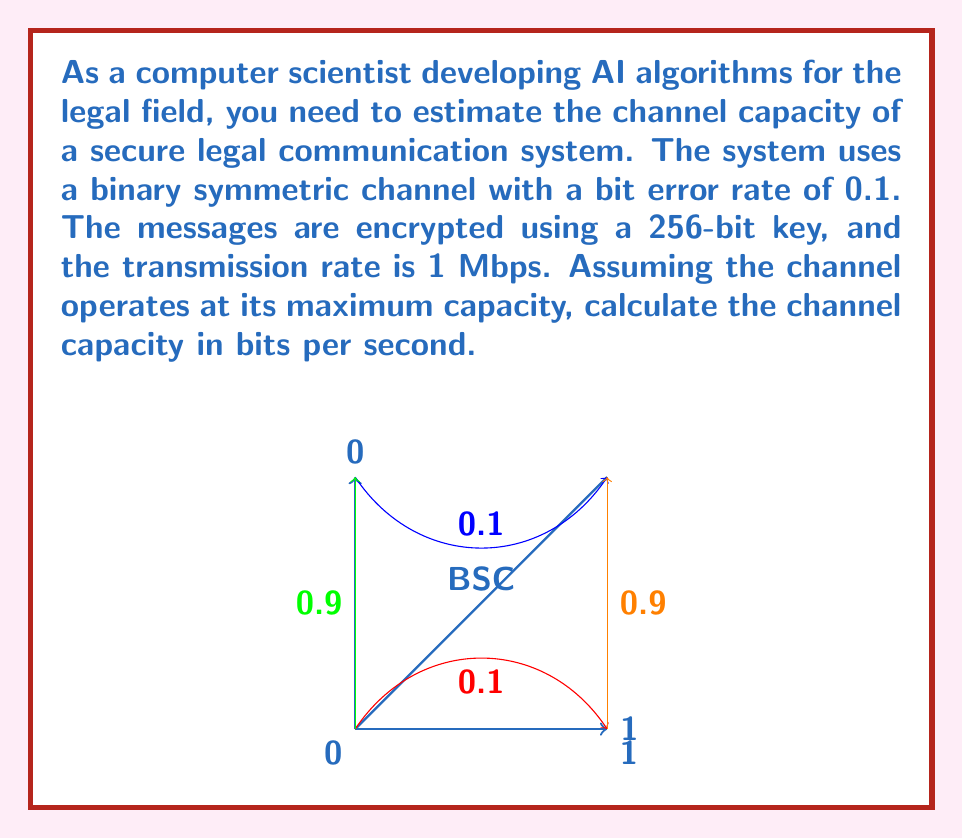What is the answer to this math problem? To solve this problem, we'll use the channel capacity formula for a binary symmetric channel and incorporate the given information:

1. The channel capacity formula for a binary symmetric channel is:
   $$C = 1 - H(p)$$
   where $C$ is the capacity in bits per channel use, and $H(p)$ is the binary entropy function.

2. The binary entropy function is defined as:
   $$H(p) = -p \log_2(p) - (1-p) \log_2(1-p)$$
   where $p$ is the bit error rate (0.1 in this case).

3. Calculate $H(p)$:
   $$H(0.1) = -0.1 \log_2(0.1) - 0.9 \log_2(0.9)$$
   $$\approx 0.3219 \text{ bits}$$

4. Calculate the channel capacity per use:
   $$C = 1 - H(0.1) \approx 1 - 0.3219 = 0.6781 \text{ bits per channel use}$$

5. The transmission rate is 1 Mbps = 1,000,000 bits per second.

6. To get the actual channel capacity in bits per second, multiply the capacity per use by the transmission rate:
   $$\text{Capacity} = 0.6781 \times 1,000,000 = 678,100 \text{ bits per second}$$

Note: The 256-bit encryption key doesn't directly affect the channel capacity calculation but ensures the security of the communication system.
Answer: 678,100 bits per second 